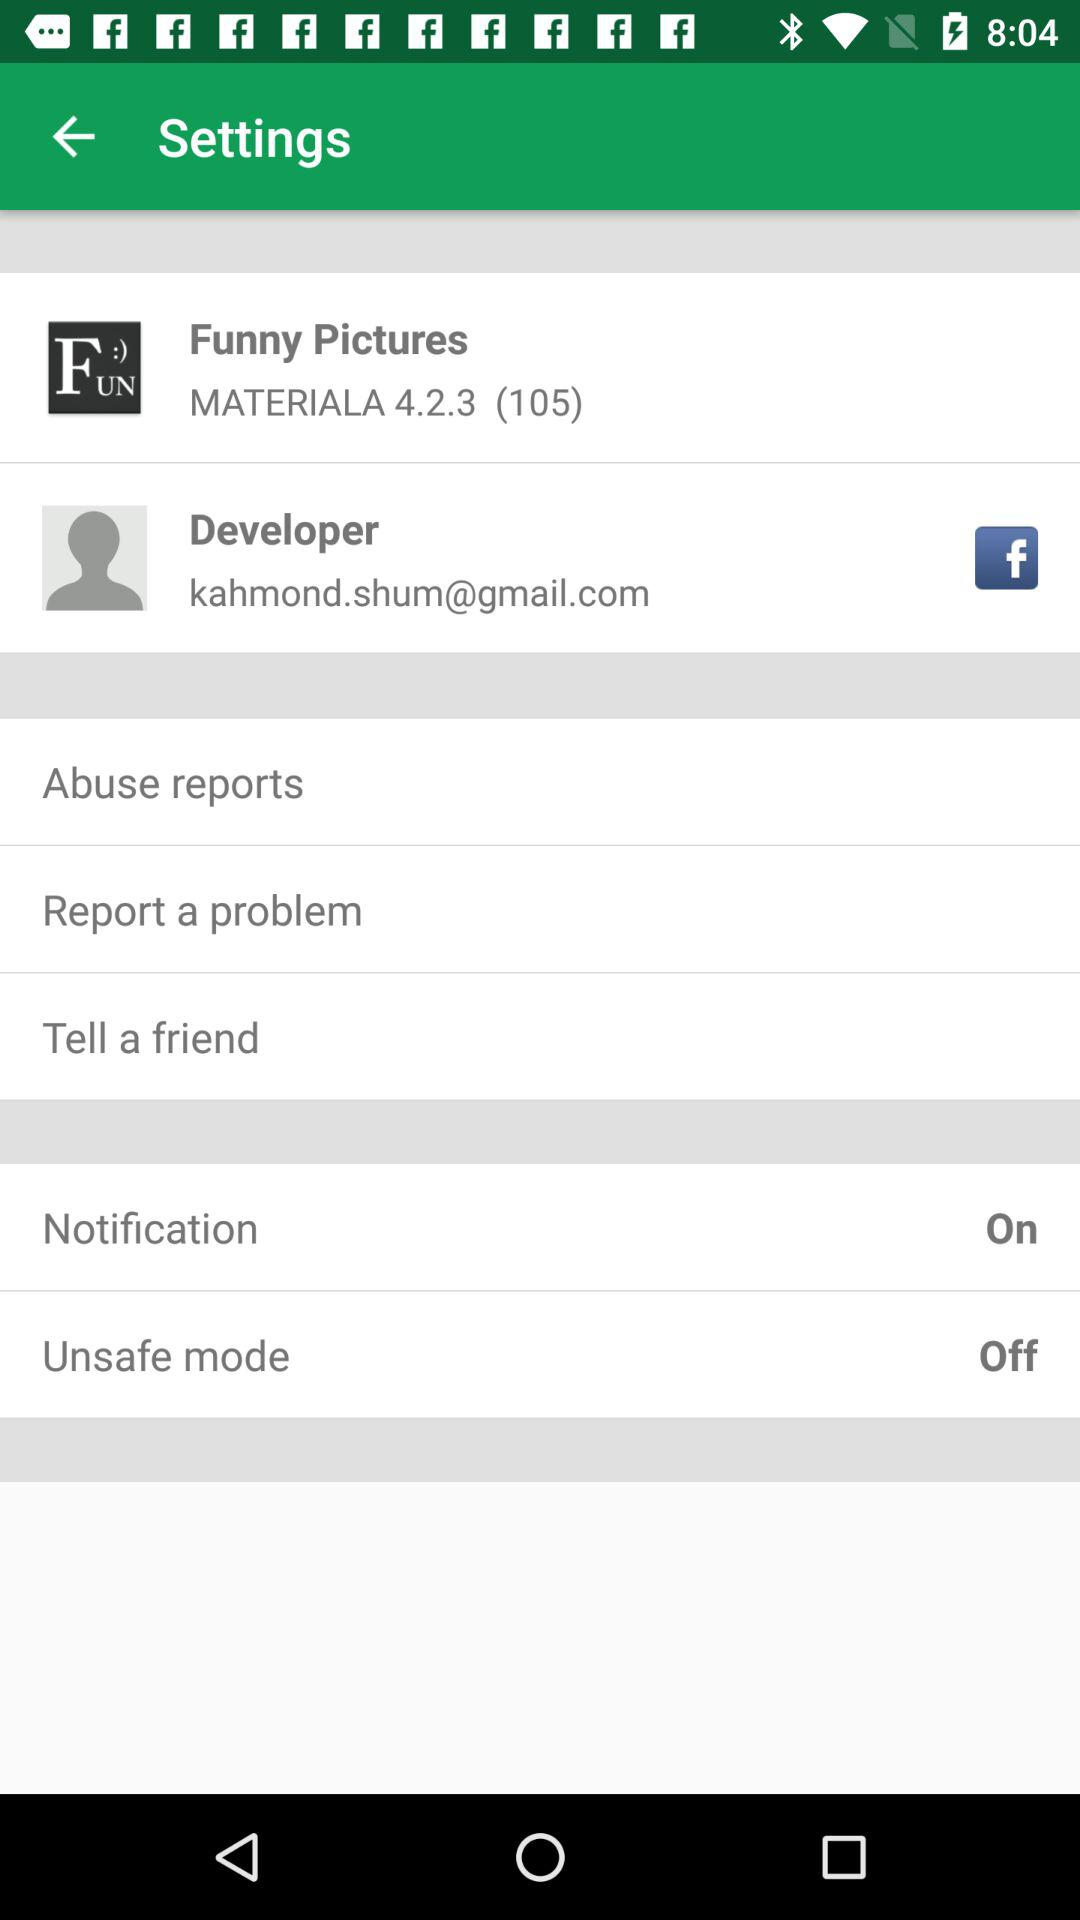What is the status of "Notification"? The status is "on". 